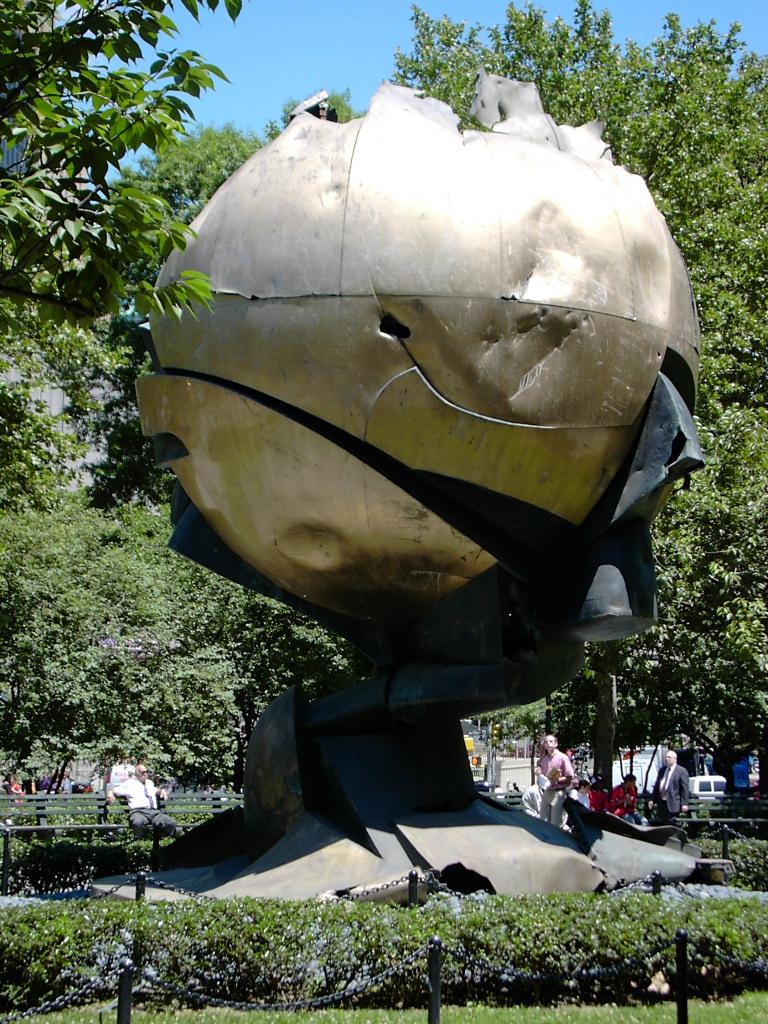What can be seen in the left corner of the image? There are trees in the left corner of the image. What can be seen in the right corner of the image? There are trees in the right corner of the image. What is located in the foreground of the image? There are people and a sculpture in the foreground of the image. What type of vegetation is at the bottom of the image? There is grass at the bottom of the image. What is visible at the top of the image? The sky is visible at the top of the image. Who is the owner of the home depicted in the image? There is no home depicted in the image, so it is not possible to determine the owner. What type of plough is being used by the people in the foreground of the image? There are no ploughs or farming activities depicted in the image; the people are simply standing in the foreground. 